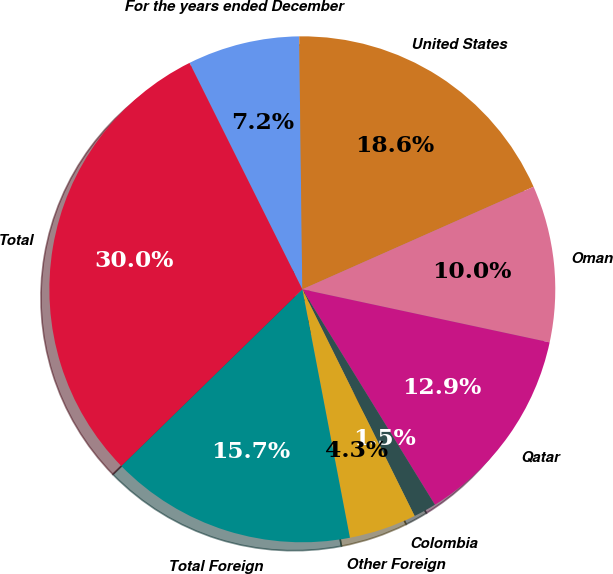<chart> <loc_0><loc_0><loc_500><loc_500><pie_chart><fcel>For the years ended December<fcel>United States<fcel>Oman<fcel>Qatar<fcel>Colombia<fcel>Other Foreign<fcel>Total Foreign<fcel>Total<nl><fcel>7.16%<fcel>18.56%<fcel>10.01%<fcel>12.86%<fcel>1.46%<fcel>4.31%<fcel>15.71%<fcel>29.96%<nl></chart> 